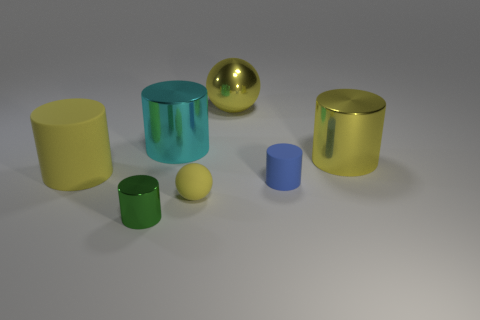What number of things are right of the yellow metallic ball and in front of the yellow matte cylinder?
Your answer should be compact. 1. Is there anything else that is the same shape as the large yellow matte object?
Give a very brief answer. Yes. What size is the yellow cylinder on the left side of the small green shiny thing?
Keep it short and to the point. Large. What number of other objects are the same color as the large metal sphere?
Offer a very short reply. 3. There is a cylinder that is to the left of the green cylinder in front of the yellow shiny ball; what is it made of?
Keep it short and to the point. Rubber. Do the rubber cylinder left of the small green shiny cylinder and the rubber ball have the same color?
Give a very brief answer. Yes. How many other large cyan metallic objects are the same shape as the cyan metallic object?
Ensure brevity in your answer.  0. There is a green thing that is the same material as the big ball; what is its size?
Keep it short and to the point. Small. There is a yellow shiny object that is left of the large yellow cylinder that is to the right of the small shiny cylinder; are there any yellow metallic objects to the right of it?
Offer a very short reply. Yes. There is a cyan object behind the blue rubber cylinder; does it have the same size as the big rubber cylinder?
Ensure brevity in your answer.  Yes. 